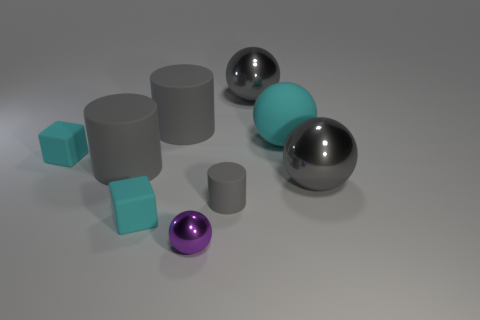How many cyan objects are the same size as the cyan rubber ball?
Offer a very short reply. 0. What color is the large rubber object that is to the right of the ball in front of the small rubber cylinder?
Provide a succinct answer. Cyan. Are there any tiny green rubber things?
Make the answer very short. No. Is the shape of the tiny purple metallic object the same as the large cyan rubber object?
Provide a short and direct response. Yes. There is a big rubber object right of the small purple thing; how many tiny gray cylinders are left of it?
Your answer should be very brief. 1. What number of gray things are on the right side of the purple metallic sphere and behind the cyan matte sphere?
Offer a very short reply. 1. How many things are tiny purple shiny things or cyan objects that are in front of the big cyan object?
Give a very brief answer. 3. The large shiny thing that is in front of the large rubber thing right of the tiny purple metal object is what shape?
Offer a very short reply. Sphere. What number of purple objects are shiny spheres or large cylinders?
Provide a short and direct response. 1. Are there any metal objects that are right of the cyan thing that is on the right side of the ball that is behind the large matte sphere?
Offer a very short reply. Yes. 